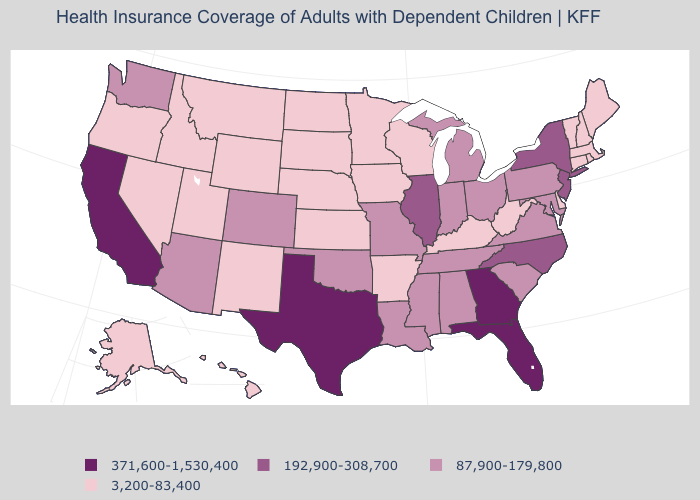What is the lowest value in the MidWest?
Keep it brief. 3,200-83,400. What is the value of Maryland?
Quick response, please. 87,900-179,800. What is the value of Georgia?
Write a very short answer. 371,600-1,530,400. What is the lowest value in the USA?
Give a very brief answer. 3,200-83,400. What is the value of Ohio?
Keep it brief. 87,900-179,800. What is the lowest value in states that border Arizona?
Keep it brief. 3,200-83,400. What is the value of Utah?
Keep it brief. 3,200-83,400. Name the states that have a value in the range 192,900-308,700?
Be succinct. Illinois, New Jersey, New York, North Carolina. What is the value of Virginia?
Concise answer only. 87,900-179,800. Among the states that border California , does Oregon have the highest value?
Answer briefly. No. Name the states that have a value in the range 192,900-308,700?
Answer briefly. Illinois, New Jersey, New York, North Carolina. How many symbols are there in the legend?
Give a very brief answer. 4. Name the states that have a value in the range 3,200-83,400?
Concise answer only. Alaska, Arkansas, Connecticut, Delaware, Hawaii, Idaho, Iowa, Kansas, Kentucky, Maine, Massachusetts, Minnesota, Montana, Nebraska, Nevada, New Hampshire, New Mexico, North Dakota, Oregon, Rhode Island, South Dakota, Utah, Vermont, West Virginia, Wisconsin, Wyoming. Is the legend a continuous bar?
Give a very brief answer. No. Does Georgia have the highest value in the USA?
Answer briefly. Yes. 